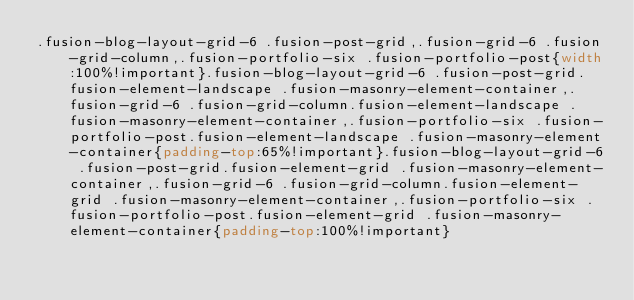Convert code to text. <code><loc_0><loc_0><loc_500><loc_500><_CSS_>.fusion-blog-layout-grid-6 .fusion-post-grid,.fusion-grid-6 .fusion-grid-column,.fusion-portfolio-six .fusion-portfolio-post{width:100%!important}.fusion-blog-layout-grid-6 .fusion-post-grid.fusion-element-landscape .fusion-masonry-element-container,.fusion-grid-6 .fusion-grid-column.fusion-element-landscape .fusion-masonry-element-container,.fusion-portfolio-six .fusion-portfolio-post.fusion-element-landscape .fusion-masonry-element-container{padding-top:65%!important}.fusion-blog-layout-grid-6 .fusion-post-grid.fusion-element-grid .fusion-masonry-element-container,.fusion-grid-6 .fusion-grid-column.fusion-element-grid .fusion-masonry-element-container,.fusion-portfolio-six .fusion-portfolio-post.fusion-element-grid .fusion-masonry-element-container{padding-top:100%!important}</code> 